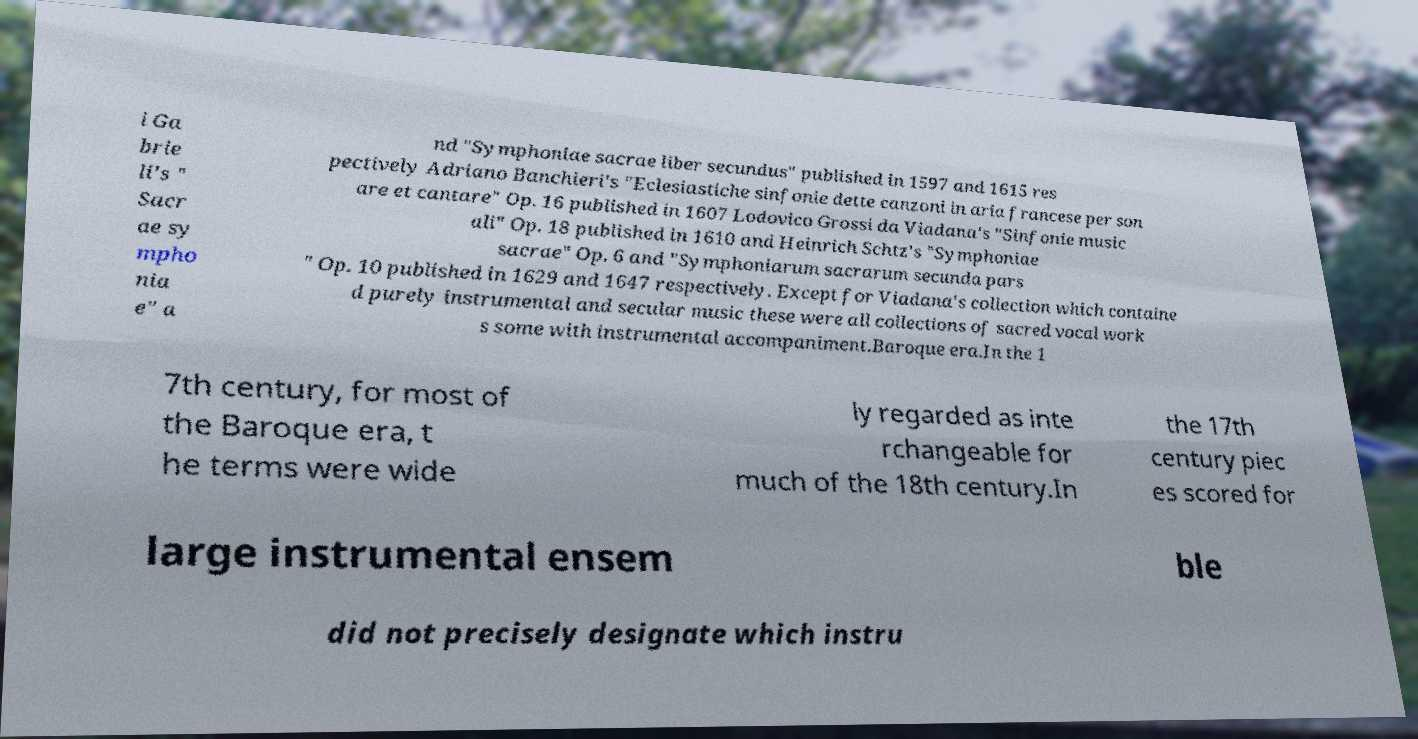Can you read and provide the text displayed in the image?This photo seems to have some interesting text. Can you extract and type it out for me? i Ga brie li's " Sacr ae sy mpho nia e" a nd "Symphoniae sacrae liber secundus" published in 1597 and 1615 res pectively Adriano Banchieri's "Eclesiastiche sinfonie dette canzoni in aria francese per son are et cantare" Op. 16 published in 1607 Lodovico Grossi da Viadana's "Sinfonie music ali" Op. 18 published in 1610 and Heinrich Schtz's "Symphoniae sacrae" Op. 6 and "Symphoniarum sacrarum secunda pars " Op. 10 published in 1629 and 1647 respectively. Except for Viadana's collection which containe d purely instrumental and secular music these were all collections of sacred vocal work s some with instrumental accompaniment.Baroque era.In the 1 7th century, for most of the Baroque era, t he terms were wide ly regarded as inte rchangeable for much of the 18th century.In the 17th century piec es scored for large instrumental ensem ble did not precisely designate which instru 